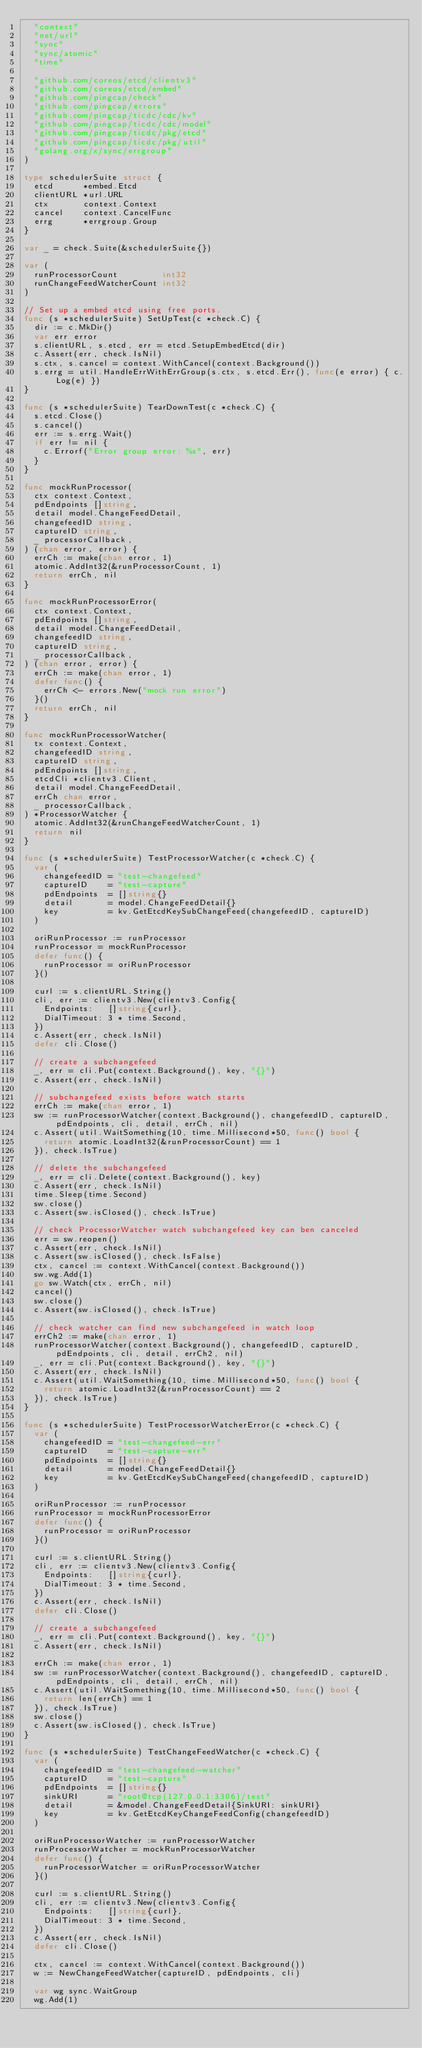<code> <loc_0><loc_0><loc_500><loc_500><_Go_>	"context"
	"net/url"
	"sync"
	"sync/atomic"
	"time"

	"github.com/coreos/etcd/clientv3"
	"github.com/coreos/etcd/embed"
	"github.com/pingcap/check"
	"github.com/pingcap/errors"
	"github.com/pingcap/ticdc/cdc/kv"
	"github.com/pingcap/ticdc/cdc/model"
	"github.com/pingcap/ticdc/pkg/etcd"
	"github.com/pingcap/ticdc/pkg/util"
	"golang.org/x/sync/errgroup"
)

type schedulerSuite struct {
	etcd      *embed.Etcd
	clientURL *url.URL
	ctx       context.Context
	cancel    context.CancelFunc
	errg      *errgroup.Group
}

var _ = check.Suite(&schedulerSuite{})

var (
	runProcessorCount         int32
	runChangeFeedWatcherCount int32
)

// Set up a embed etcd using free ports.
func (s *schedulerSuite) SetUpTest(c *check.C) {
	dir := c.MkDir()
	var err error
	s.clientURL, s.etcd, err = etcd.SetupEmbedEtcd(dir)
	c.Assert(err, check.IsNil)
	s.ctx, s.cancel = context.WithCancel(context.Background())
	s.errg = util.HandleErrWithErrGroup(s.ctx, s.etcd.Err(), func(e error) { c.Log(e) })
}

func (s *schedulerSuite) TearDownTest(c *check.C) {
	s.etcd.Close()
	s.cancel()
	err := s.errg.Wait()
	if err != nil {
		c.Errorf("Error group error: %s", err)
	}
}

func mockRunProcessor(
	ctx context.Context,
	pdEndpoints []string,
	detail model.ChangeFeedDetail,
	changefeedID string,
	captureID string,
	_ processorCallback,
) (chan error, error) {
	errCh := make(chan error, 1)
	atomic.AddInt32(&runProcessorCount, 1)
	return errCh, nil
}

func mockRunProcessorError(
	ctx context.Context,
	pdEndpoints []string,
	detail model.ChangeFeedDetail,
	changefeedID string,
	captureID string,
	_ processorCallback,
) (chan error, error) {
	errCh := make(chan error, 1)
	defer func() {
		errCh <- errors.New("mock run error")
	}()
	return errCh, nil
}

func mockRunProcessorWatcher(
	tx context.Context,
	changefeedID string,
	captureID string,
	pdEndpoints []string,
	etcdCli *clientv3.Client,
	detail model.ChangeFeedDetail,
	errCh chan error,
	_ processorCallback,
) *ProcessorWatcher {
	atomic.AddInt32(&runChangeFeedWatcherCount, 1)
	return nil
}

func (s *schedulerSuite) TestProcessorWatcher(c *check.C) {
	var (
		changefeedID = "test-changefeed"
		captureID    = "test-capture"
		pdEndpoints  = []string{}
		detail       = model.ChangeFeedDetail{}
		key          = kv.GetEtcdKeySubChangeFeed(changefeedID, captureID)
	)

	oriRunProcessor := runProcessor
	runProcessor = mockRunProcessor
	defer func() {
		runProcessor = oriRunProcessor
	}()

	curl := s.clientURL.String()
	cli, err := clientv3.New(clientv3.Config{
		Endpoints:   []string{curl},
		DialTimeout: 3 * time.Second,
	})
	c.Assert(err, check.IsNil)
	defer cli.Close()

	// create a subchangefeed
	_, err = cli.Put(context.Background(), key, "{}")
	c.Assert(err, check.IsNil)

	// subchangefeed exists before watch starts
	errCh := make(chan error, 1)
	sw := runProcessorWatcher(context.Background(), changefeedID, captureID, pdEndpoints, cli, detail, errCh, nil)
	c.Assert(util.WaitSomething(10, time.Millisecond*50, func() bool {
		return atomic.LoadInt32(&runProcessorCount) == 1
	}), check.IsTrue)

	// delete the subchangefeed
	_, err = cli.Delete(context.Background(), key)
	c.Assert(err, check.IsNil)
	time.Sleep(time.Second)
	sw.close()
	c.Assert(sw.isClosed(), check.IsTrue)

	// check ProcessorWatcher watch subchangefeed key can ben canceled
	err = sw.reopen()
	c.Assert(err, check.IsNil)
	c.Assert(sw.isClosed(), check.IsFalse)
	ctx, cancel := context.WithCancel(context.Background())
	sw.wg.Add(1)
	go sw.Watch(ctx, errCh, nil)
	cancel()
	sw.close()
	c.Assert(sw.isClosed(), check.IsTrue)

	// check watcher can find new subchangefeed in watch loop
	errCh2 := make(chan error, 1)
	runProcessorWatcher(context.Background(), changefeedID, captureID, pdEndpoints, cli, detail, errCh2, nil)
	_, err = cli.Put(context.Background(), key, "{}")
	c.Assert(err, check.IsNil)
	c.Assert(util.WaitSomething(10, time.Millisecond*50, func() bool {
		return atomic.LoadInt32(&runProcessorCount) == 2
	}), check.IsTrue)
}

func (s *schedulerSuite) TestProcessorWatcherError(c *check.C) {
	var (
		changefeedID = "test-changefeed-err"
		captureID    = "test-capture-err"
		pdEndpoints  = []string{}
		detail       = model.ChangeFeedDetail{}
		key          = kv.GetEtcdKeySubChangeFeed(changefeedID, captureID)
	)

	oriRunProcessor := runProcessor
	runProcessor = mockRunProcessorError
	defer func() {
		runProcessor = oriRunProcessor
	}()

	curl := s.clientURL.String()
	cli, err := clientv3.New(clientv3.Config{
		Endpoints:   []string{curl},
		DialTimeout: 3 * time.Second,
	})
	c.Assert(err, check.IsNil)
	defer cli.Close()

	// create a subchangefeed
	_, err = cli.Put(context.Background(), key, "{}")
	c.Assert(err, check.IsNil)

	errCh := make(chan error, 1)
	sw := runProcessorWatcher(context.Background(), changefeedID, captureID, pdEndpoints, cli, detail, errCh, nil)
	c.Assert(util.WaitSomething(10, time.Millisecond*50, func() bool {
		return len(errCh) == 1
	}), check.IsTrue)
	sw.close()
	c.Assert(sw.isClosed(), check.IsTrue)
}

func (s *schedulerSuite) TestChangeFeedWatcher(c *check.C) {
	var (
		changefeedID = "test-changefeed-watcher"
		captureID    = "test-capture"
		pdEndpoints  = []string{}
		sinkURI      = "root@tcp(127.0.0.1:3306)/test"
		detail       = &model.ChangeFeedDetail{SinkURI: sinkURI}
		key          = kv.GetEtcdKeyChangeFeedConfig(changefeedID)
	)

	oriRunProcessorWatcher := runProcessorWatcher
	runProcessorWatcher = mockRunProcessorWatcher
	defer func() {
		runProcessorWatcher = oriRunProcessorWatcher
	}()

	curl := s.clientURL.String()
	cli, err := clientv3.New(clientv3.Config{
		Endpoints:   []string{curl},
		DialTimeout: 3 * time.Second,
	})
	c.Assert(err, check.IsNil)
	defer cli.Close()

	ctx, cancel := context.WithCancel(context.Background())
	w := NewChangeFeedWatcher(captureID, pdEndpoints, cli)

	var wg sync.WaitGroup
	wg.Add(1)</code> 